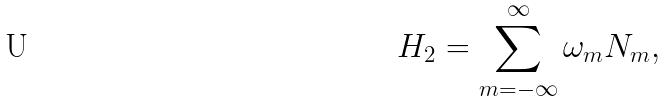Convert formula to latex. <formula><loc_0><loc_0><loc_500><loc_500>H _ { 2 } = \sum _ { m = - \infty } ^ { \infty } \omega _ { m } N _ { m } ,</formula> 